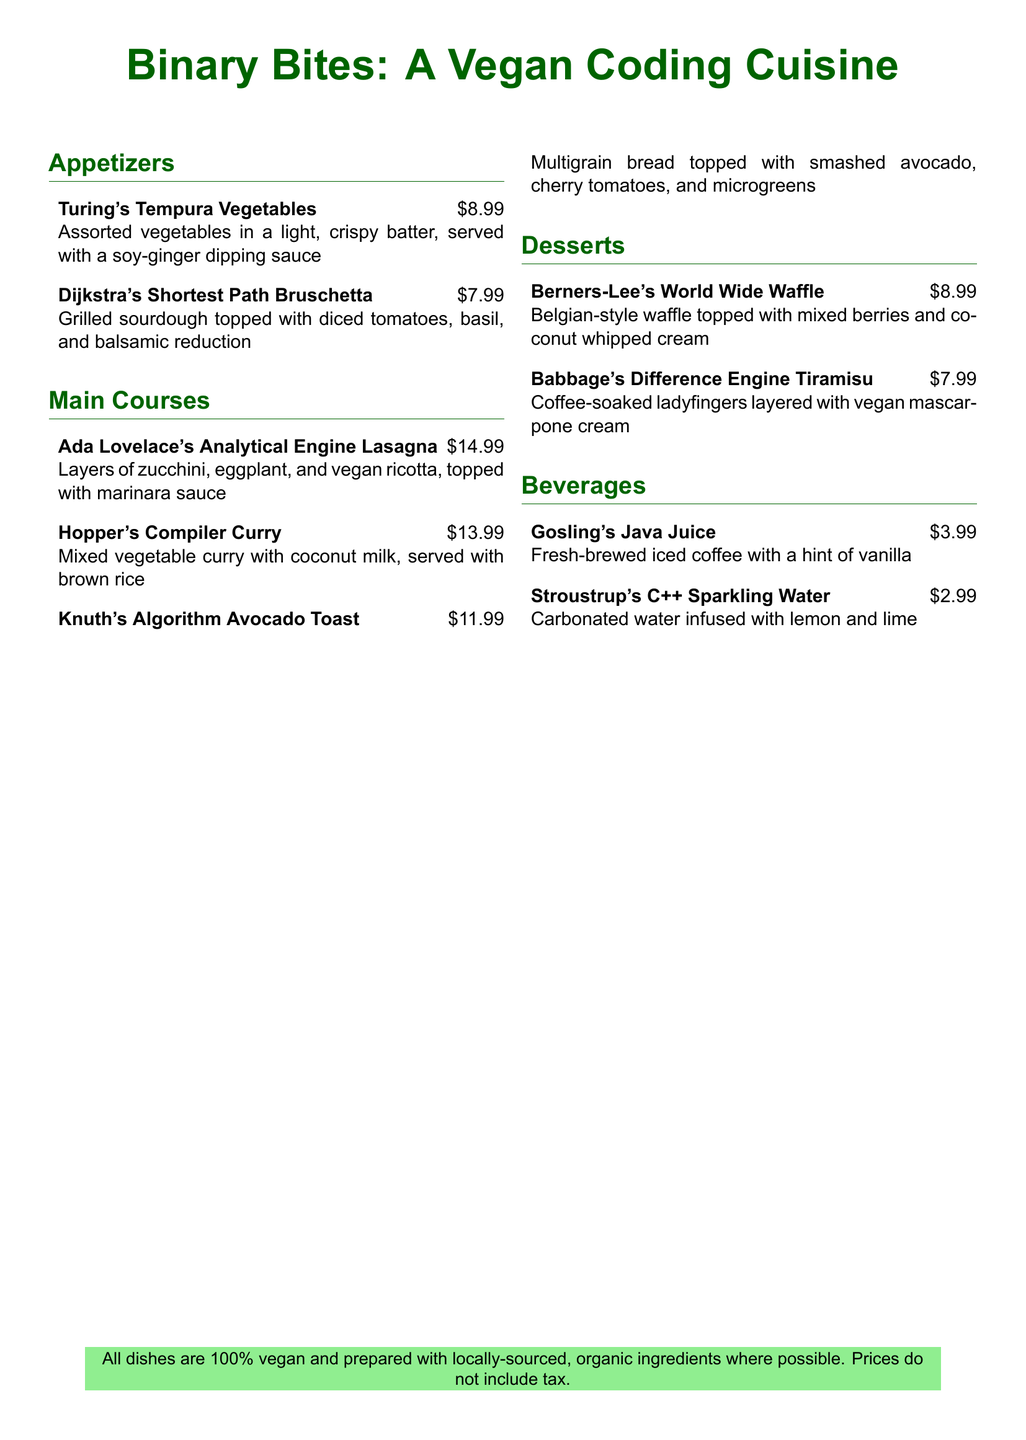What is the price of Turing's Tempura Vegetables? The price listed for Turing's Tempura Vegetables in the document is $8.99.
Answer: $8.99 What is the main ingredient in Hopper's Compiler Curry? The main ingredient mentioned for Hopper's Compiler Curry is mixed vegetables.
Answer: Mixed vegetables How many appetizers are listed on the menu? The menu lists a total of 2 appetizers in the appetizers section.
Answer: 2 Which dessert is named after Tim Berners-Lee? The dessert named after Tim Berners-Lee is the World Wide Waffle.
Answer: World Wide Waffle What beverage is priced at $2.99? The beverage priced at $2.99 is Stroustrup's C++ Sparkling Water.
Answer: Stroustrup's C++ Sparkling Water What is the total number of main courses available? There are a total of 3 main courses available on the menu.
Answer: 3 What type of bread is used in Knuth's Algorithm Avocado Toast? The type of bread used in Knuth's Algorithm Avocado Toast is multigrain bread.
Answer: Multigrain bread How is Berners-Lee's World Wide Waffle described? The dessert is described as a Belgian-style waffle topped with mixed berries and coconut whipped cream.
Answer: Belgian-style waffle topped with mixed berries and coconut whipped cream 